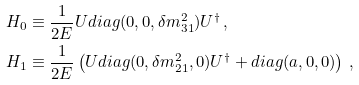Convert formula to latex. <formula><loc_0><loc_0><loc_500><loc_500>H _ { 0 } & \equiv \frac { 1 } { 2 E } U d i a g ( 0 , 0 , \delta m ^ { 2 } _ { 3 1 } ) U ^ { \dagger } \, , \\ H _ { 1 } & \equiv \frac { 1 } { 2 E } \left ( U d i a g ( 0 , \delta m ^ { 2 } _ { 2 1 } , 0 ) U ^ { \dagger } + d i a g ( a , 0 , 0 ) \right ) \, ,</formula> 